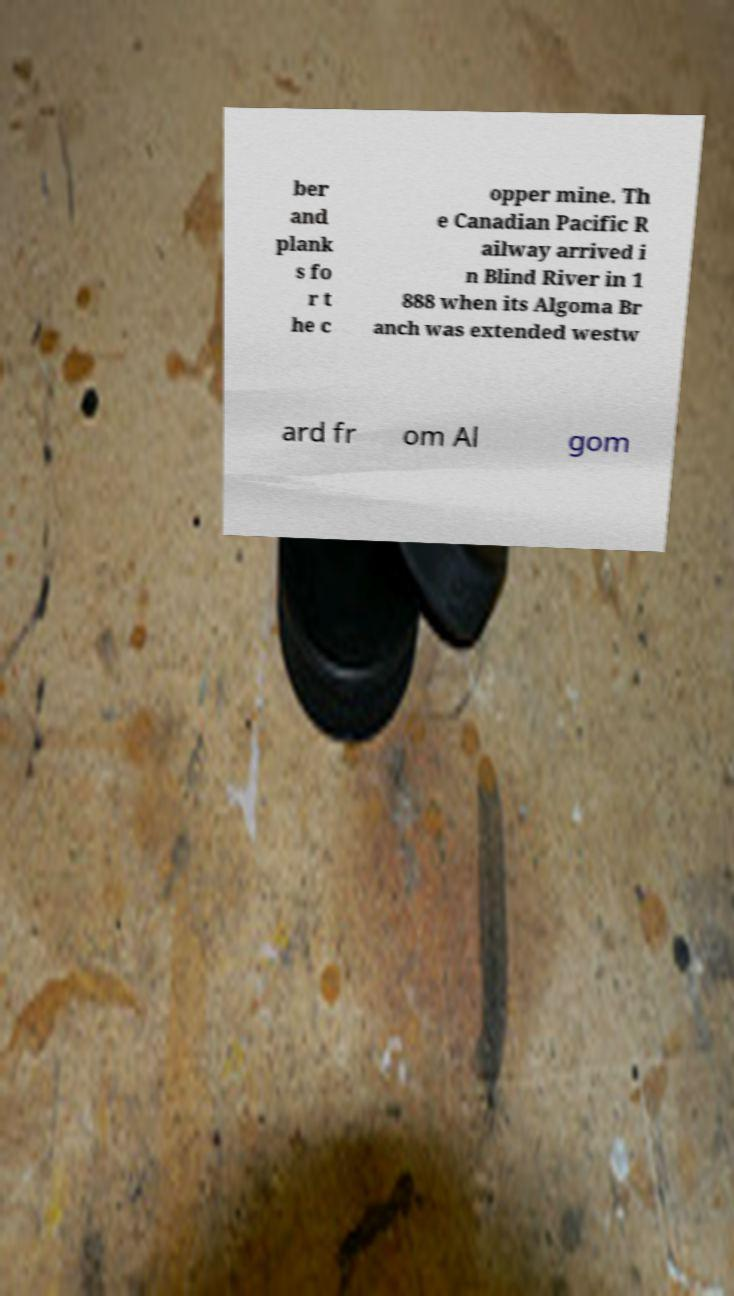I need the written content from this picture converted into text. Can you do that? ber and plank s fo r t he c opper mine. Th e Canadian Pacific R ailway arrived i n Blind River in 1 888 when its Algoma Br anch was extended westw ard fr om Al gom 